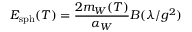Convert formula to latex. <formula><loc_0><loc_0><loc_500><loc_500>E _ { s p h } ( T ) = \frac { 2 m _ { W } ( T ) } { \alpha _ { W } } B ( \lambda / g ^ { 2 } )</formula> 